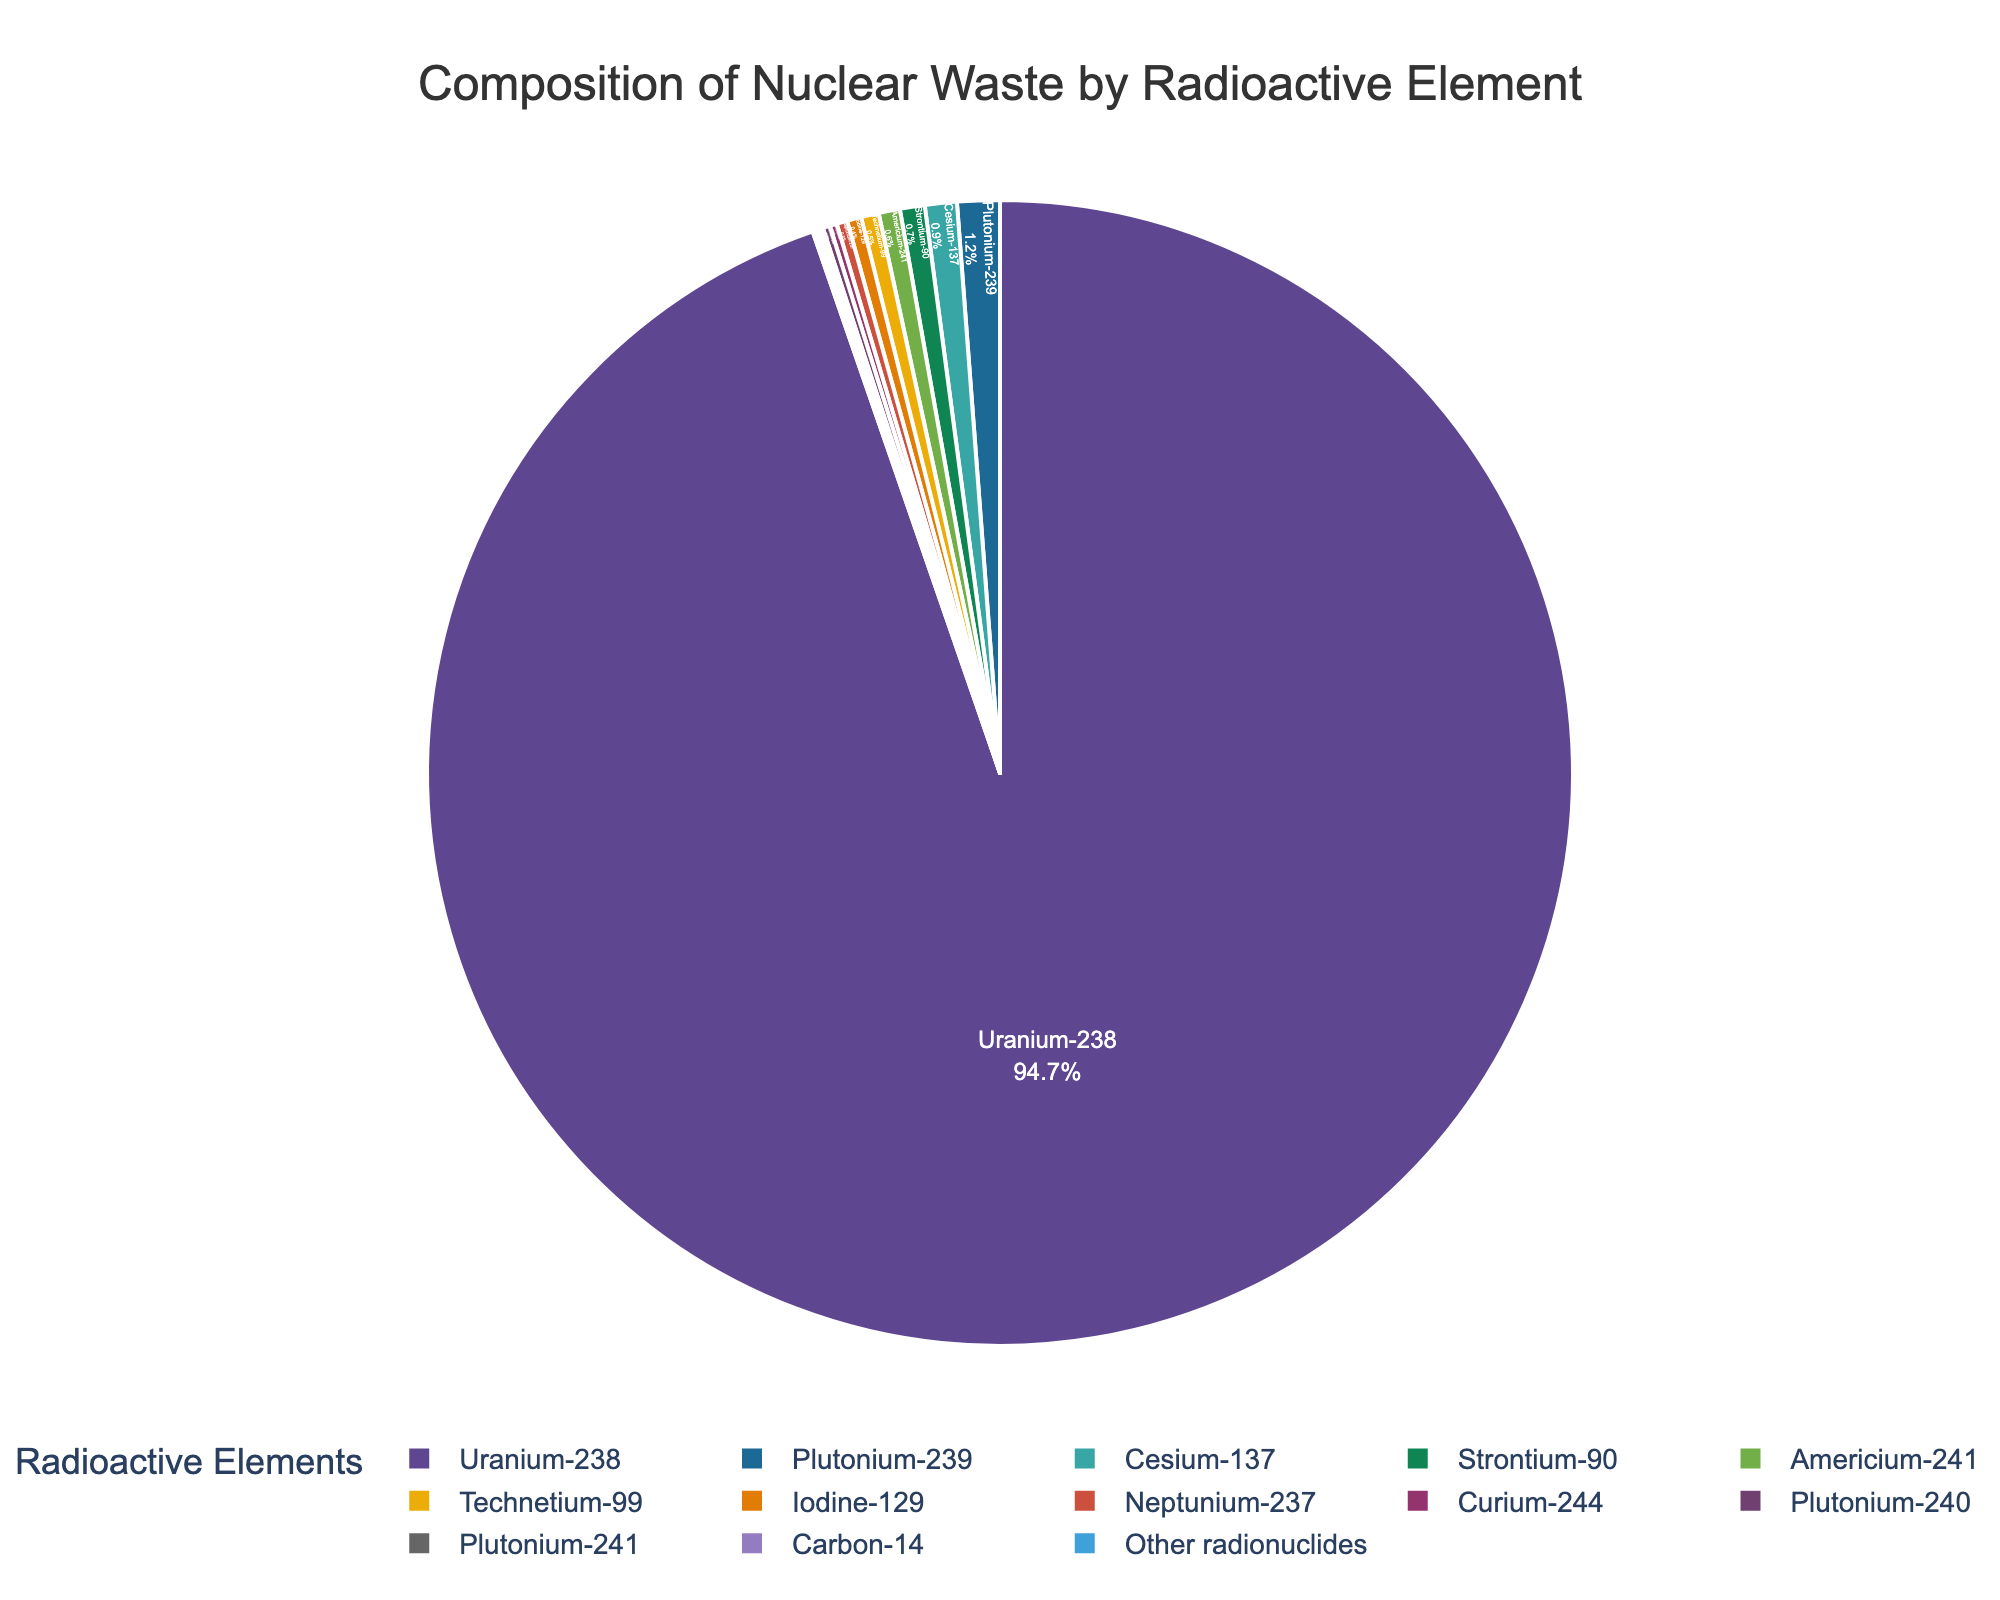What is the combined percentage of Plutonium-239 and Plutonium-240? First, identify the percentages for Plutonium-239 and Plutonium-240, which are 1.2% and 0.2% respectively. Then, sum these percentages: 1.2 + 0.2 = 1.4%.
Answer: 1.4% Which radioactive element has the second highest composition in nuclear waste? First, observe the pie chart to identify the largest percentage, which is for Uranium-238 at 94.7%. Then find the element with the next largest percentage, which is Plutonium-239 at 1.2%.
Answer: Plutonium-239 What are the percentages of Cesium-137 and Strontium-90, and which one is higher? Check the chart for the percentages of Cesium-137 and Strontium-90, which are 0.9% and 0.7% respectively. Compare them to see which is higher.
Answer: Cesium-137 What is the average percentage of Americium-241, Technetium-99, and Iodine-129? Add the percentages of Americium-241 (0.6%), Technetium-99 (0.5%), and Iodine-129 (0.4%) to get a total of: 0.6 + 0.5 + 0.4 = 1.5%. Then divide by 3 for the average: 1.5 / 3 = 0.5%.
Answer: 0.5% What fraction of the total nuclear waste is composed of components other than Uranium-238? Identify the percentage of Uranium-238 as 94.7%. Subtract this from 100% to find the remaining fraction: 100 - 94.7 = 5.3%.
Answer: 5.3% Which two elements have an equal percentage composition in the nuclear waste, and what is this percentage? Search the chart for elements with the same percentage. Plutonium-240 and Curium-244 both have a composition of 0.2%.
Answer: Plutonium-240 and Curium-244, 0.2% How much greater is the percentage of Uranium-238 compared to the combined percentage of Plutonium-239, Cesium-137, and Strontium-90? First, find the sum of the percentages of Plutonium-239 (1.2%), Cesium-137 (0.9%), and Strontium-90 (0.7%), which is 1.2 + 0.9 + 0.7 = 2.8%. Then, subtract this from the percentage of Uranium-238: 94.7 - 2.8 = 91.9%.
Answer: 91.9% Which radioactive elements have a percentage composition of 0.1%, and how many such elements are there? Identify elements with 0.1% composition in the pie chart. These are Plutonium-241, Carbon-14, and Other radionuclides, making a total of 3 elements.
Answer: 3 elements 